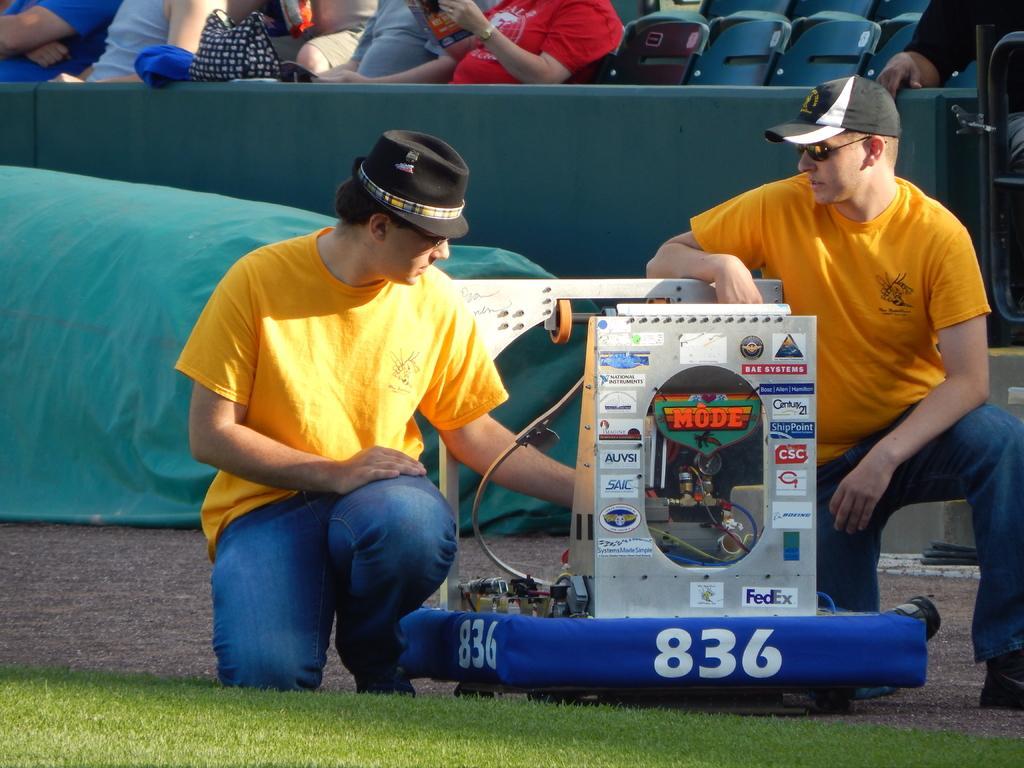Please provide a concise description of this image. In this image there are two men kneeling on the ground. In between them there is a machine. Behind them there are people sitting on the chairs. At the bottom there is grass on the ground. 